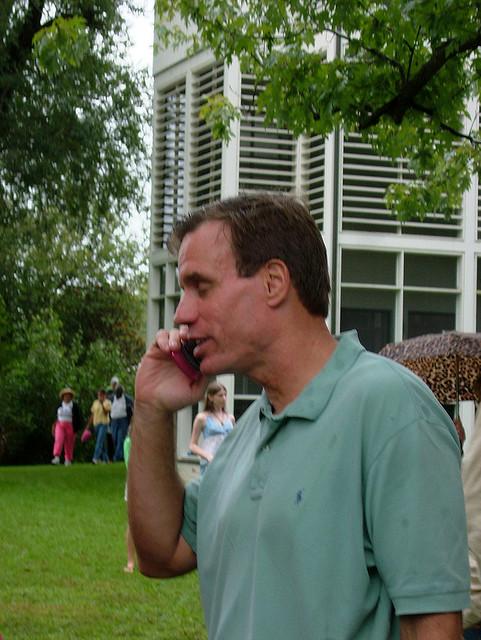Is the man wearing glasses?
Keep it brief. No. Is the man on the phone?
Be succinct. Yes. Is the face of the cell phone that is touching the face predominantly metal or glass?
Short answer required. Glass. What color is the man's shirt?
Answer briefly. Green. Are his eyes open?
Short answer required. No. What brand shirt?
Quick response, please. Polo. 